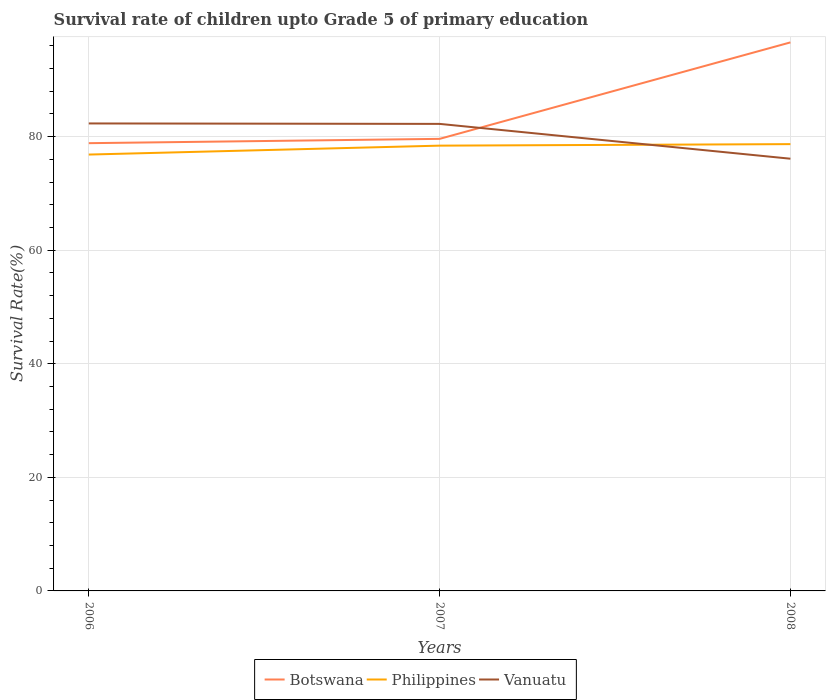How many different coloured lines are there?
Provide a succinct answer. 3. Is the number of lines equal to the number of legend labels?
Make the answer very short. Yes. Across all years, what is the maximum survival rate of children in Vanuatu?
Make the answer very short. 76.11. In which year was the survival rate of children in Philippines maximum?
Your response must be concise. 2006. What is the total survival rate of children in Botswana in the graph?
Keep it short and to the point. -17.75. What is the difference between the highest and the second highest survival rate of children in Vanuatu?
Offer a very short reply. 6.21. What is the difference between the highest and the lowest survival rate of children in Botswana?
Offer a terse response. 1. Is the survival rate of children in Vanuatu strictly greater than the survival rate of children in Philippines over the years?
Offer a very short reply. No. How many lines are there?
Provide a short and direct response. 3. How many years are there in the graph?
Your answer should be very brief. 3. What is the difference between two consecutive major ticks on the Y-axis?
Your answer should be very brief. 20. Are the values on the major ticks of Y-axis written in scientific E-notation?
Offer a very short reply. No. Does the graph contain any zero values?
Your answer should be compact. No. Does the graph contain grids?
Make the answer very short. Yes. What is the title of the graph?
Give a very brief answer. Survival rate of children upto Grade 5 of primary education. What is the label or title of the Y-axis?
Offer a very short reply. Survival Rate(%). What is the Survival Rate(%) of Botswana in 2006?
Your answer should be very brief. 78.85. What is the Survival Rate(%) of Philippines in 2006?
Ensure brevity in your answer.  76.84. What is the Survival Rate(%) of Vanuatu in 2006?
Ensure brevity in your answer.  82.32. What is the Survival Rate(%) in Botswana in 2007?
Your answer should be very brief. 79.6. What is the Survival Rate(%) in Philippines in 2007?
Offer a terse response. 78.41. What is the Survival Rate(%) in Vanuatu in 2007?
Your response must be concise. 82.24. What is the Survival Rate(%) in Botswana in 2008?
Provide a succinct answer. 96.59. What is the Survival Rate(%) in Philippines in 2008?
Offer a very short reply. 78.68. What is the Survival Rate(%) of Vanuatu in 2008?
Ensure brevity in your answer.  76.11. Across all years, what is the maximum Survival Rate(%) in Botswana?
Your answer should be compact. 96.59. Across all years, what is the maximum Survival Rate(%) in Philippines?
Your answer should be very brief. 78.68. Across all years, what is the maximum Survival Rate(%) of Vanuatu?
Offer a very short reply. 82.32. Across all years, what is the minimum Survival Rate(%) of Botswana?
Offer a very short reply. 78.85. Across all years, what is the minimum Survival Rate(%) in Philippines?
Offer a terse response. 76.84. Across all years, what is the minimum Survival Rate(%) of Vanuatu?
Your response must be concise. 76.11. What is the total Survival Rate(%) of Botswana in the graph?
Your answer should be very brief. 255.04. What is the total Survival Rate(%) in Philippines in the graph?
Provide a short and direct response. 233.93. What is the total Survival Rate(%) of Vanuatu in the graph?
Offer a terse response. 240.67. What is the difference between the Survival Rate(%) of Botswana in 2006 and that in 2007?
Your response must be concise. -0.76. What is the difference between the Survival Rate(%) in Philippines in 2006 and that in 2007?
Make the answer very short. -1.57. What is the difference between the Survival Rate(%) in Vanuatu in 2006 and that in 2007?
Your answer should be very brief. 0.08. What is the difference between the Survival Rate(%) of Botswana in 2006 and that in 2008?
Your answer should be compact. -17.75. What is the difference between the Survival Rate(%) of Philippines in 2006 and that in 2008?
Provide a succinct answer. -1.84. What is the difference between the Survival Rate(%) in Vanuatu in 2006 and that in 2008?
Make the answer very short. 6.21. What is the difference between the Survival Rate(%) in Botswana in 2007 and that in 2008?
Give a very brief answer. -16.99. What is the difference between the Survival Rate(%) of Philippines in 2007 and that in 2008?
Ensure brevity in your answer.  -0.27. What is the difference between the Survival Rate(%) in Vanuatu in 2007 and that in 2008?
Keep it short and to the point. 6.13. What is the difference between the Survival Rate(%) of Botswana in 2006 and the Survival Rate(%) of Philippines in 2007?
Your answer should be compact. 0.44. What is the difference between the Survival Rate(%) in Botswana in 2006 and the Survival Rate(%) in Vanuatu in 2007?
Provide a short and direct response. -3.4. What is the difference between the Survival Rate(%) in Philippines in 2006 and the Survival Rate(%) in Vanuatu in 2007?
Your response must be concise. -5.4. What is the difference between the Survival Rate(%) in Botswana in 2006 and the Survival Rate(%) in Philippines in 2008?
Your response must be concise. 0.17. What is the difference between the Survival Rate(%) of Botswana in 2006 and the Survival Rate(%) of Vanuatu in 2008?
Give a very brief answer. 2.74. What is the difference between the Survival Rate(%) in Philippines in 2006 and the Survival Rate(%) in Vanuatu in 2008?
Give a very brief answer. 0.73. What is the difference between the Survival Rate(%) in Botswana in 2007 and the Survival Rate(%) in Philippines in 2008?
Keep it short and to the point. 0.93. What is the difference between the Survival Rate(%) in Botswana in 2007 and the Survival Rate(%) in Vanuatu in 2008?
Give a very brief answer. 3.49. What is the difference between the Survival Rate(%) in Philippines in 2007 and the Survival Rate(%) in Vanuatu in 2008?
Make the answer very short. 2.3. What is the average Survival Rate(%) in Botswana per year?
Offer a terse response. 85.01. What is the average Survival Rate(%) in Philippines per year?
Make the answer very short. 77.98. What is the average Survival Rate(%) in Vanuatu per year?
Keep it short and to the point. 80.22. In the year 2006, what is the difference between the Survival Rate(%) in Botswana and Survival Rate(%) in Philippines?
Provide a succinct answer. 2.01. In the year 2006, what is the difference between the Survival Rate(%) in Botswana and Survival Rate(%) in Vanuatu?
Give a very brief answer. -3.48. In the year 2006, what is the difference between the Survival Rate(%) in Philippines and Survival Rate(%) in Vanuatu?
Provide a short and direct response. -5.48. In the year 2007, what is the difference between the Survival Rate(%) in Botswana and Survival Rate(%) in Philippines?
Provide a succinct answer. 1.19. In the year 2007, what is the difference between the Survival Rate(%) of Botswana and Survival Rate(%) of Vanuatu?
Your response must be concise. -2.64. In the year 2007, what is the difference between the Survival Rate(%) of Philippines and Survival Rate(%) of Vanuatu?
Make the answer very short. -3.83. In the year 2008, what is the difference between the Survival Rate(%) in Botswana and Survival Rate(%) in Philippines?
Offer a terse response. 17.92. In the year 2008, what is the difference between the Survival Rate(%) in Botswana and Survival Rate(%) in Vanuatu?
Provide a succinct answer. 20.48. In the year 2008, what is the difference between the Survival Rate(%) in Philippines and Survival Rate(%) in Vanuatu?
Keep it short and to the point. 2.57. What is the ratio of the Survival Rate(%) in Botswana in 2006 to that in 2007?
Provide a succinct answer. 0.99. What is the ratio of the Survival Rate(%) in Vanuatu in 2006 to that in 2007?
Offer a very short reply. 1. What is the ratio of the Survival Rate(%) of Botswana in 2006 to that in 2008?
Your response must be concise. 0.82. What is the ratio of the Survival Rate(%) in Philippines in 2006 to that in 2008?
Provide a short and direct response. 0.98. What is the ratio of the Survival Rate(%) of Vanuatu in 2006 to that in 2008?
Provide a succinct answer. 1.08. What is the ratio of the Survival Rate(%) in Botswana in 2007 to that in 2008?
Make the answer very short. 0.82. What is the ratio of the Survival Rate(%) of Philippines in 2007 to that in 2008?
Provide a succinct answer. 1. What is the ratio of the Survival Rate(%) of Vanuatu in 2007 to that in 2008?
Offer a terse response. 1.08. What is the difference between the highest and the second highest Survival Rate(%) of Botswana?
Make the answer very short. 16.99. What is the difference between the highest and the second highest Survival Rate(%) of Philippines?
Provide a short and direct response. 0.27. What is the difference between the highest and the second highest Survival Rate(%) of Vanuatu?
Your response must be concise. 0.08. What is the difference between the highest and the lowest Survival Rate(%) of Botswana?
Provide a short and direct response. 17.75. What is the difference between the highest and the lowest Survival Rate(%) in Philippines?
Offer a very short reply. 1.84. What is the difference between the highest and the lowest Survival Rate(%) in Vanuatu?
Offer a terse response. 6.21. 